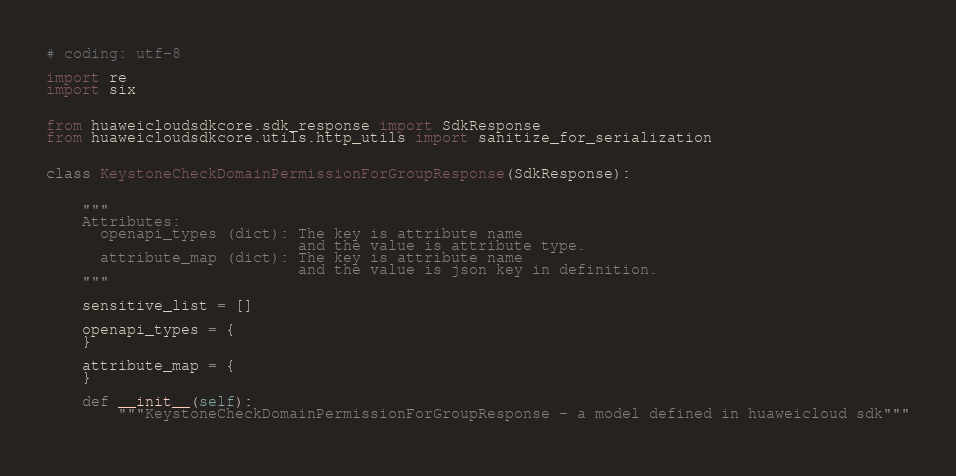<code> <loc_0><loc_0><loc_500><loc_500><_Python_># coding: utf-8

import re
import six


from huaweicloudsdkcore.sdk_response import SdkResponse
from huaweicloudsdkcore.utils.http_utils import sanitize_for_serialization


class KeystoneCheckDomainPermissionForGroupResponse(SdkResponse):


    """
    Attributes:
      openapi_types (dict): The key is attribute name
                            and the value is attribute type.
      attribute_map (dict): The key is attribute name
                            and the value is json key in definition.
    """

    sensitive_list = []

    openapi_types = {
    }

    attribute_map = {
    }

    def __init__(self):
        """KeystoneCheckDomainPermissionForGroupResponse - a model defined in huaweicloud sdk"""
        </code> 